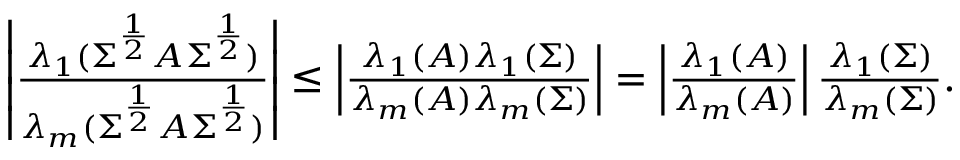Convert formula to latex. <formula><loc_0><loc_0><loc_500><loc_500>\begin{array} { r l r } & { \left | \frac { \lambda _ { 1 } ( \Sigma ^ { \frac { 1 } { 2 } } A \Sigma ^ { \frac { 1 } { 2 } } ) } { \lambda _ { m } ( \Sigma ^ { \frac { 1 } { 2 } } A \Sigma ^ { \frac { 1 } { 2 } } ) } \right | \leq \left | \frac { \lambda _ { 1 } ( A ) \lambda _ { 1 } ( \Sigma ) } { \lambda _ { m } ( A ) \lambda _ { m } ( \Sigma ) } \right | = \left | \frac { \lambda _ { 1 } ( A ) } { \lambda _ { m } ( A ) } \right | \frac { \lambda _ { 1 } ( \Sigma ) } { \lambda _ { m } ( \Sigma ) } . } \end{array}</formula> 